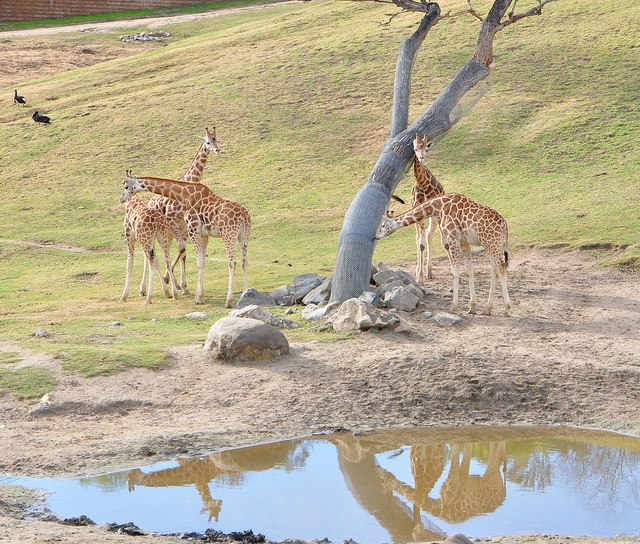Describe the objects in this image and their specific colors. I can see giraffe in maroon, darkgray, gray, and tan tones, giraffe in maroon, gray, and tan tones, giraffe in maroon, tan, and ivory tones, giraffe in maroon, tan, and gray tones, and giraffe in maroon, gray, tan, and ivory tones in this image. 